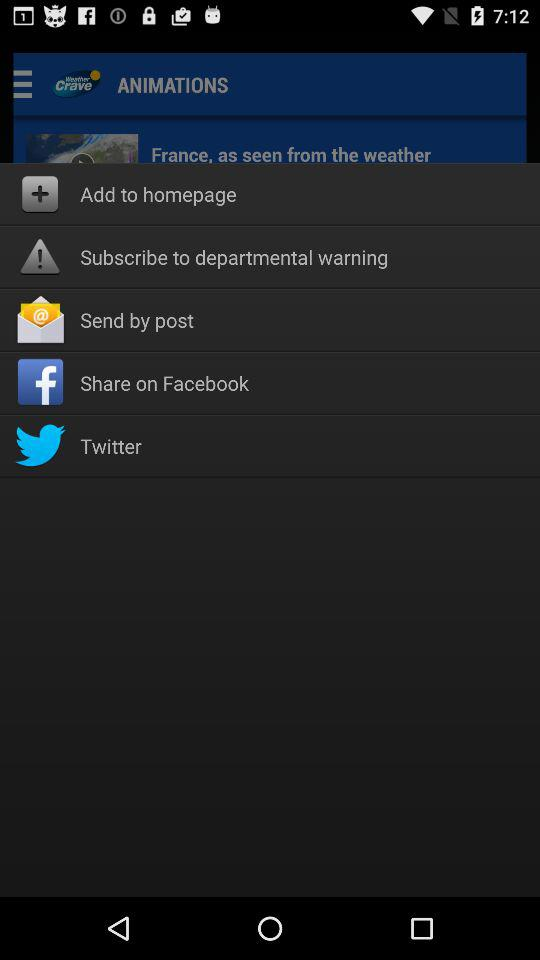Which are the different sharing options? The different sharing options are "post", "Facebook" and "Twitter". 